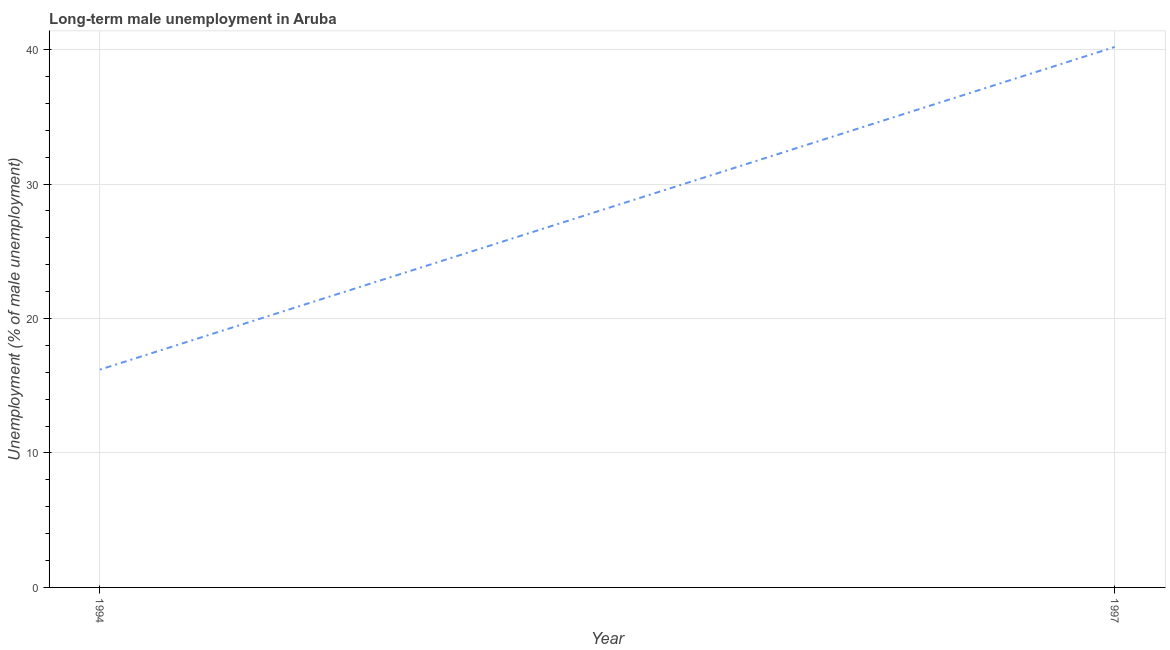What is the long-term male unemployment in 1994?
Your response must be concise. 16.2. Across all years, what is the maximum long-term male unemployment?
Provide a short and direct response. 40.2. Across all years, what is the minimum long-term male unemployment?
Provide a succinct answer. 16.2. In which year was the long-term male unemployment minimum?
Make the answer very short. 1994. What is the sum of the long-term male unemployment?
Keep it short and to the point. 56.4. What is the difference between the long-term male unemployment in 1994 and 1997?
Offer a very short reply. -24. What is the average long-term male unemployment per year?
Keep it short and to the point. 28.2. What is the median long-term male unemployment?
Make the answer very short. 28.2. Do a majority of the years between 1994 and 1997 (inclusive) have long-term male unemployment greater than 4 %?
Offer a very short reply. Yes. What is the ratio of the long-term male unemployment in 1994 to that in 1997?
Offer a terse response. 0.4. Is the long-term male unemployment in 1994 less than that in 1997?
Provide a short and direct response. Yes. How many lines are there?
Offer a very short reply. 1. How many years are there in the graph?
Provide a succinct answer. 2. Does the graph contain any zero values?
Offer a terse response. No. Does the graph contain grids?
Keep it short and to the point. Yes. What is the title of the graph?
Your answer should be compact. Long-term male unemployment in Aruba. What is the label or title of the X-axis?
Ensure brevity in your answer.  Year. What is the label or title of the Y-axis?
Give a very brief answer. Unemployment (% of male unemployment). What is the Unemployment (% of male unemployment) of 1994?
Make the answer very short. 16.2. What is the Unemployment (% of male unemployment) of 1997?
Your answer should be very brief. 40.2. What is the ratio of the Unemployment (% of male unemployment) in 1994 to that in 1997?
Your response must be concise. 0.4. 